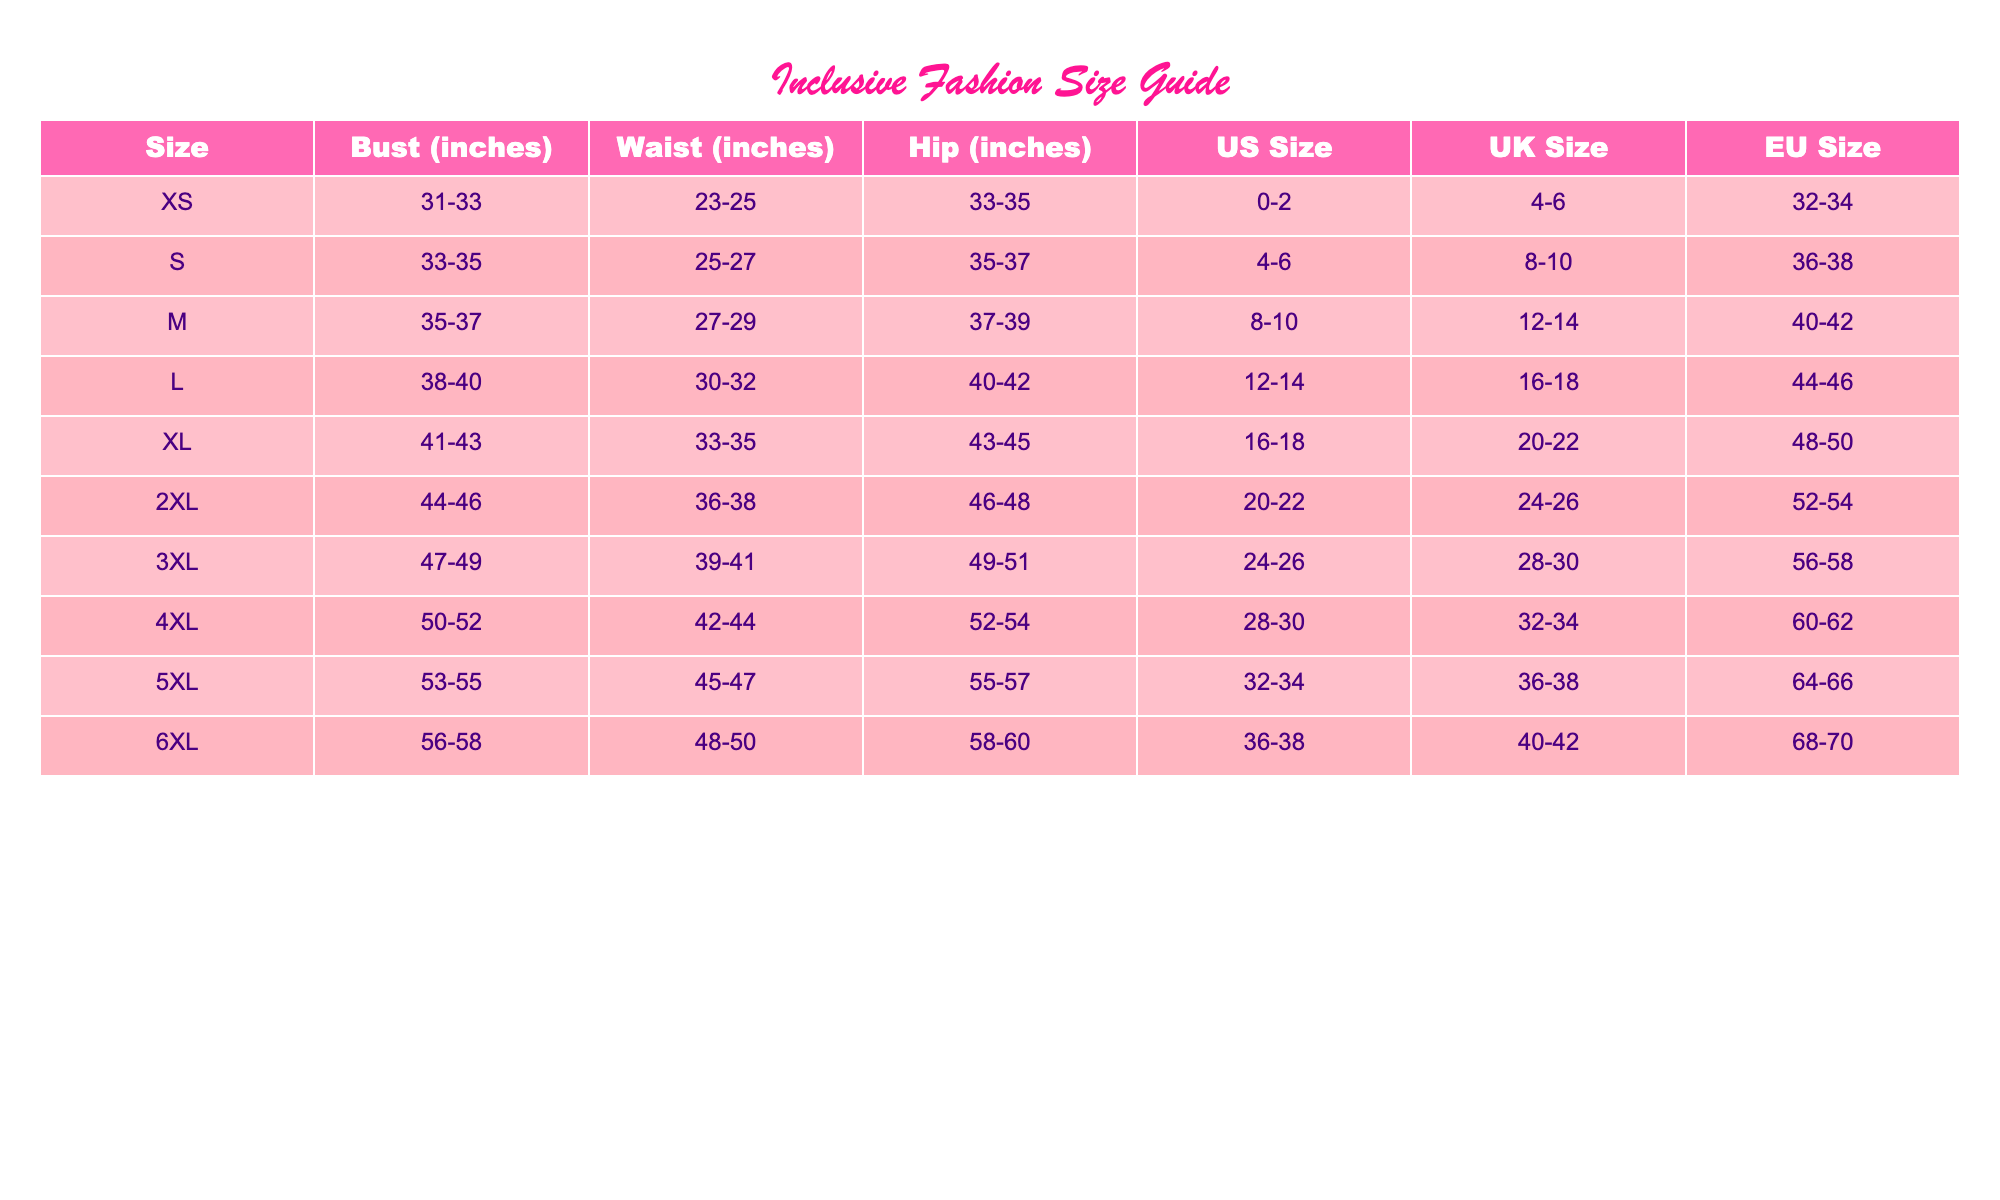What is the US size for a person with a bust measurement of 35-37 inches? According to the table, the size corresponding to a bust measurement of 35-37 inches is M. The US size for M is listed as 8-10.
Answer: 8-10 Which size has a hip measurement of 52-54 inches? The table shows that the 4XL size has a hip measurement of 52-54 inches.
Answer: 4XL Is the UK size for a 2XL the same as the US size for an XL? The UK size for 2XL is 24-26, while the US size for XL is 16-18. Therefore, they are not the same.
Answer: No What is the average bust measurement across all sizes? The bust measurements for each size are: XS (32), S (34), M (36), L (39), XL (42), 2XL (45), 3XL (48), 4XL (51), 5XL (54), 6XL (57). Summing these gives 32 + 34 + 36 + 39 + 42 + 45 + 48 + 51 + 54 + 57 =  438. There are 10 sizes, so the average is 438/10 = 43.8 inches.
Answer: 43.8 How many sizes have a waist measurement that exceeds 30 inches? By examining the waist measurements, L (30-32), XL (33-35), 2XL (36-38), 3XL (39-41), 4XL (42-44), 5XL (45-47), and 6XL (48-50) all exceed 30 inches. There are 6 sizes total.
Answer: 6 What is the difference in the hip measurements between an XL and a 3XL? The hip measurement for XL is 43-45 inches, and for 3XL it is 49-51 inches. To find the difference, we consider the ranges: the lower range difference is 49 - 45 = 4 inches and the upper range difference is 51 - 43 = 8 inches. Thus, the difference in hip measurements is 4-8 inches.
Answer: 4-8 inches Which size has the most significant range in hip measurements? The range of hip measurements is calculated for each size: XS (2 inches), S (2 inches), M (2 inches), L (2 inches), XL (2 inches), 2XL (2 inches), 3XL (2 inches), 4XL (2 inches), 5XL (2 inches), 6XL (2 inches). Since all sizes have the same range of 2 inches, there isn't one that stands out.
Answer: All sizes (2 inches) 